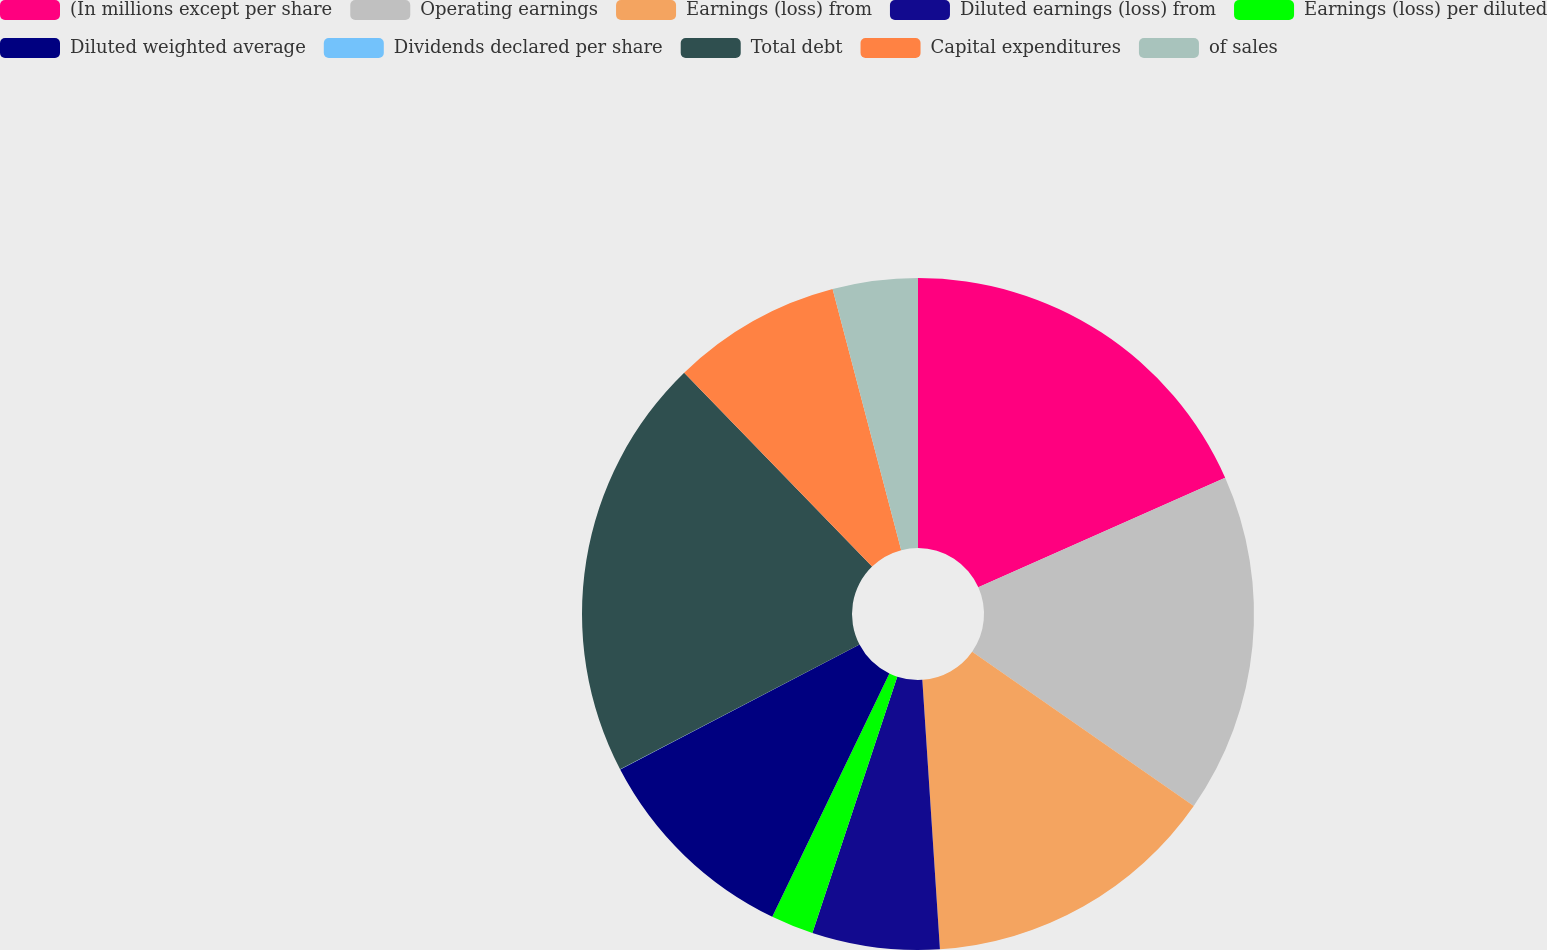<chart> <loc_0><loc_0><loc_500><loc_500><pie_chart><fcel>(In millions except per share<fcel>Operating earnings<fcel>Earnings (loss) from<fcel>Diluted earnings (loss) from<fcel>Earnings (loss) per diluted<fcel>Diluted weighted average<fcel>Dividends declared per share<fcel>Total debt<fcel>Capital expenditures<fcel>of sales<nl><fcel>18.36%<fcel>16.32%<fcel>14.28%<fcel>6.13%<fcel>2.05%<fcel>10.2%<fcel>0.01%<fcel>20.4%<fcel>8.16%<fcel>4.09%<nl></chart> 